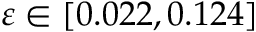Convert formula to latex. <formula><loc_0><loc_0><loc_500><loc_500>\varepsilon \in [ 0 . 0 2 2 , 0 . 1 2 4 ]</formula> 